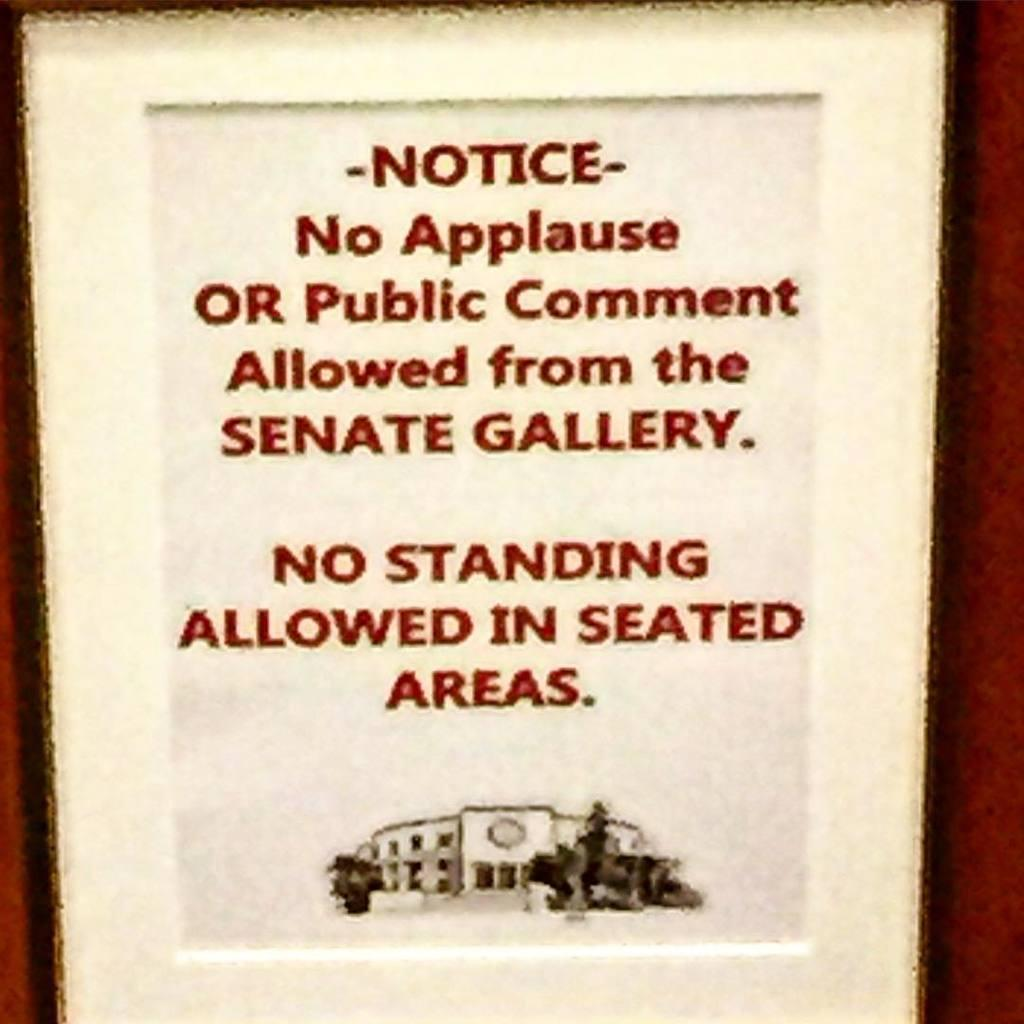<image>
Provide a brief description of the given image. A poster displaying rules for the Senate Gallery. 